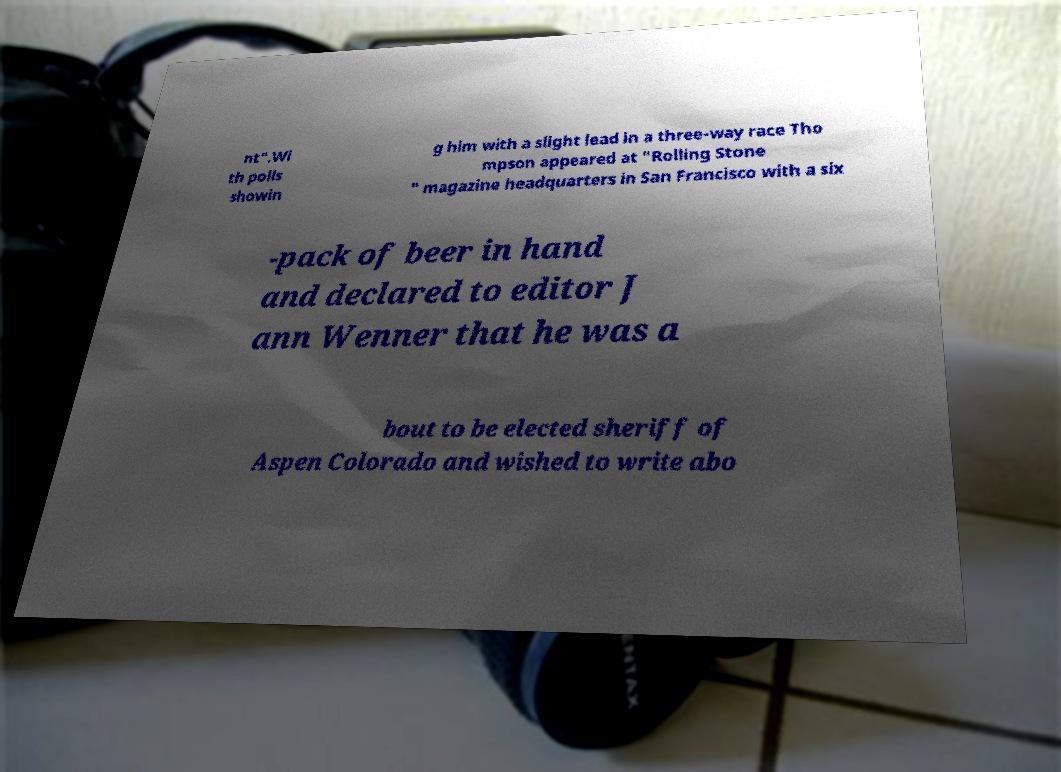Please identify and transcribe the text found in this image. nt".Wi th polls showin g him with a slight lead in a three-way race Tho mpson appeared at "Rolling Stone " magazine headquarters in San Francisco with a six -pack of beer in hand and declared to editor J ann Wenner that he was a bout to be elected sheriff of Aspen Colorado and wished to write abo 